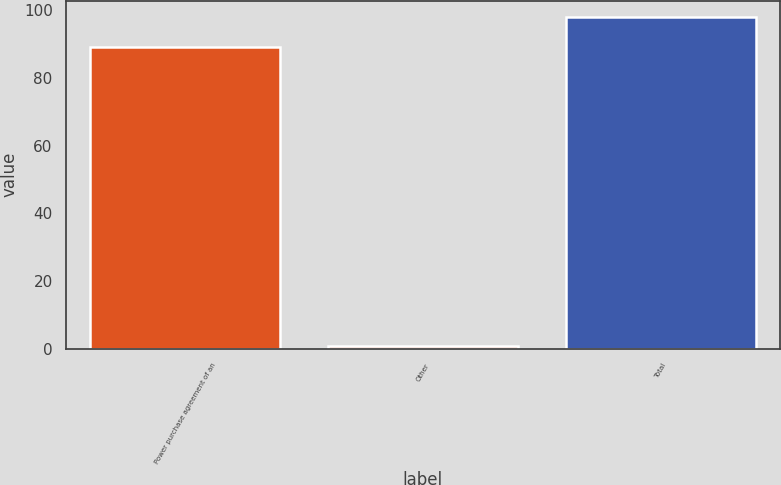<chart> <loc_0><loc_0><loc_500><loc_500><bar_chart><fcel>Power purchase agreement of an<fcel>Other<fcel>Total<nl><fcel>89<fcel>1<fcel>97.9<nl></chart> 